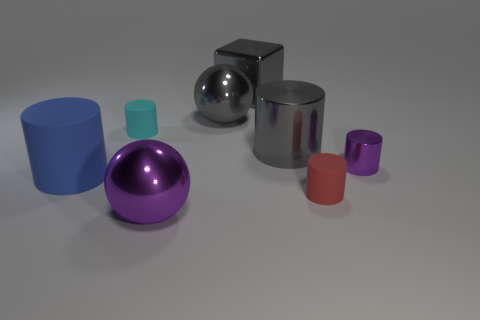What number of big objects are purple balls or blue objects?
Keep it short and to the point. 2. Are there the same number of large cylinders to the left of the big cube and shiny cylinders?
Your answer should be very brief. No. There is a purple metal thing that is in front of the tiny purple shiny object; are there any tiny objects in front of it?
Ensure brevity in your answer.  No. What number of other objects are the same color as the large matte thing?
Provide a short and direct response. 0. The small metal cylinder is what color?
Provide a succinct answer. Purple. There is a rubber cylinder that is both in front of the cyan object and behind the red object; what is its size?
Provide a short and direct response. Large. What number of objects are either things to the left of the gray cylinder or small purple cylinders?
Make the answer very short. 6. What shape is the other purple thing that is made of the same material as the tiny purple object?
Offer a very short reply. Sphere. What is the shape of the big purple thing?
Give a very brief answer. Sphere. What is the color of the cylinder that is both left of the large gray cylinder and behind the purple metal cylinder?
Give a very brief answer. Cyan. 